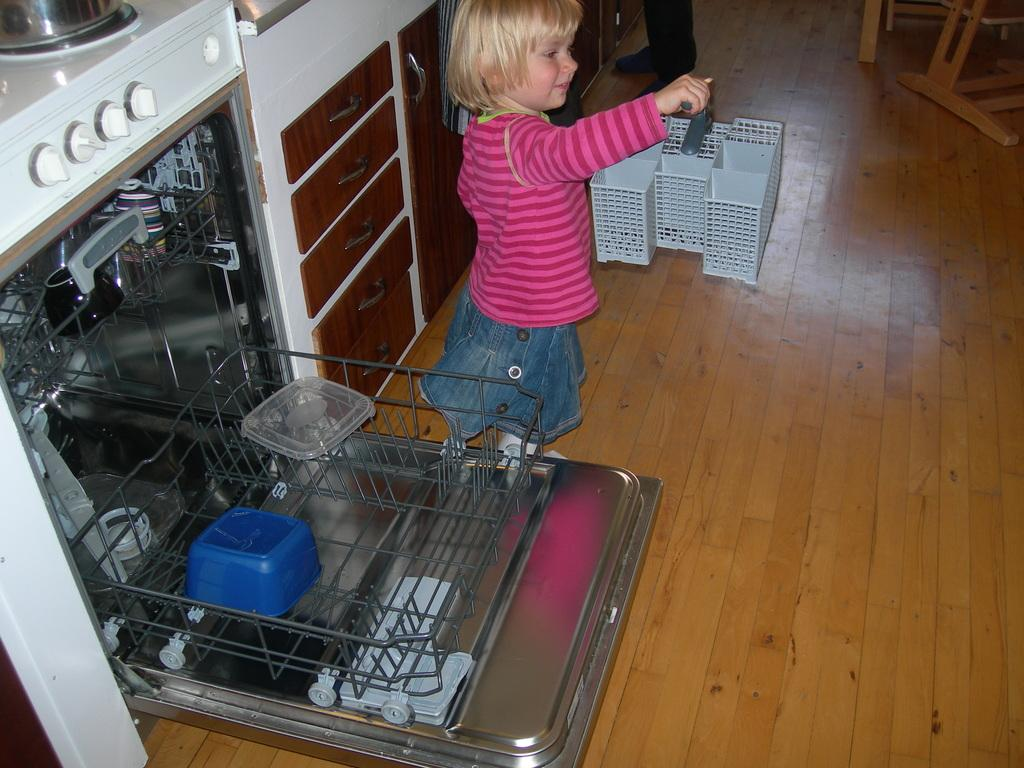What is the main subject in the image? There is a child in the image. What else can be seen on the floor in the image? A person's legs are visible on the floor. What type of furniture is present in the image? There are cupboards and drawers in the image. Can you describe the objects in the image? There are some objects in the image, but their specific details are not mentioned in the facts. What color is the coil that is wrapped around the child's legs in the image? There is no coil wrapped around the child's legs in the image. 